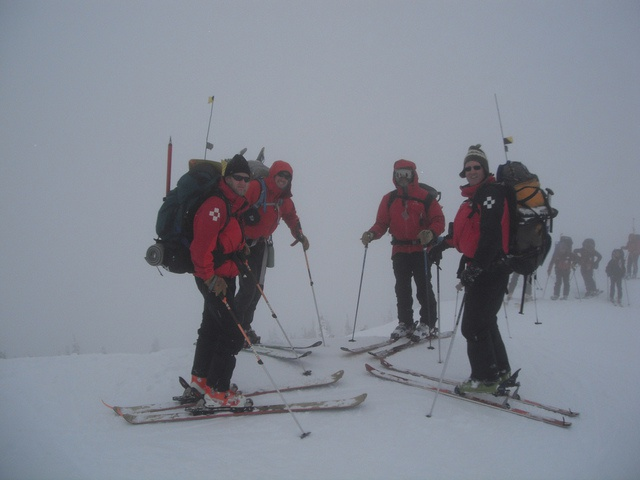Describe the objects in this image and their specific colors. I can see people in gray, black, and maroon tones, people in gray, black, and maroon tones, people in gray, black, maroon, and brown tones, people in gray, black, maroon, and brown tones, and backpack in gray, black, and brown tones in this image. 